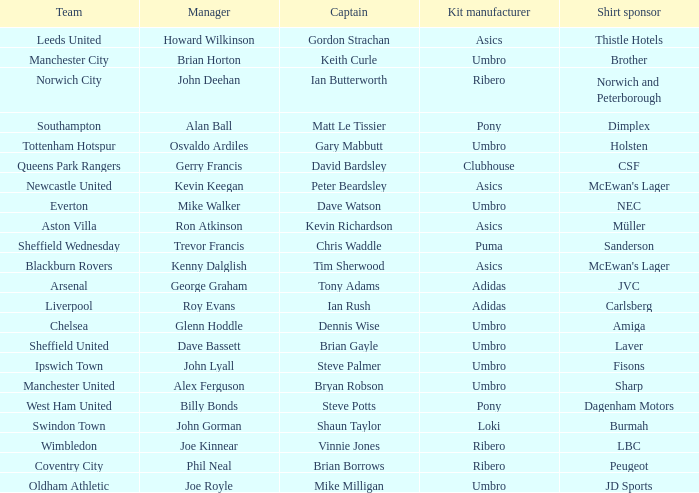Which manager has Manchester City as the team? Brian Horton. 